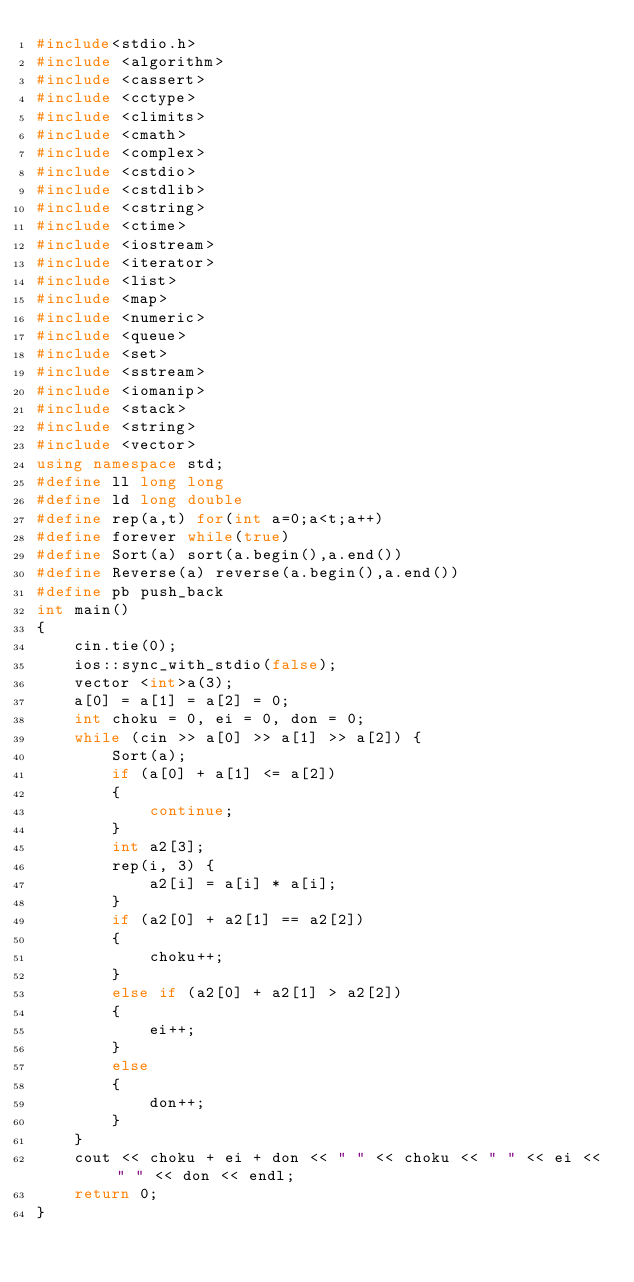<code> <loc_0><loc_0><loc_500><loc_500><_C++_>#include<stdio.h>
#include <algorithm>
#include <cassert>
#include <cctype>
#include <climits>
#include <cmath>
#include <complex>
#include <cstdio>
#include <cstdlib>
#include <cstring>
#include <ctime>
#include <iostream>
#include <iterator>
#include <list>
#include <map>     
#include <numeric>
#include <queue>
#include <set>
#include <sstream>
#include <iomanip>
#include <stack>
#include <string>
#include <vector>
using namespace std;
#define ll long long
#define ld long double
#define rep(a,t) for(int a=0;a<t;a++) 
#define forever while(true)
#define Sort(a) sort(a.begin(),a.end())
#define Reverse(a) reverse(a.begin(),a.end())
#define pb push_back
int main()
{
	cin.tie(0);
	ios::sync_with_stdio(false);
	vector <int>a(3);
	a[0] = a[1] = a[2] = 0;
	int choku = 0, ei = 0, don = 0;
	while (cin >> a[0] >> a[1] >> a[2]) {
		Sort(a);
		if (a[0] + a[1] <= a[2])
		{
			continue;
		}
		int a2[3];
		rep(i, 3) {
			a2[i] = a[i] * a[i];
		}
		if (a2[0] + a2[1] == a2[2]) 
		{ 
			choku++;
		}
		else if (a2[0] + a2[1] > a2[2]) 
		{ 
			ei++;
		}
		else 
		{
			don++;
		}
	}
	cout << choku + ei + don << " " << choku << " " << ei << " " << don << endl;
	return 0;
}
</code> 